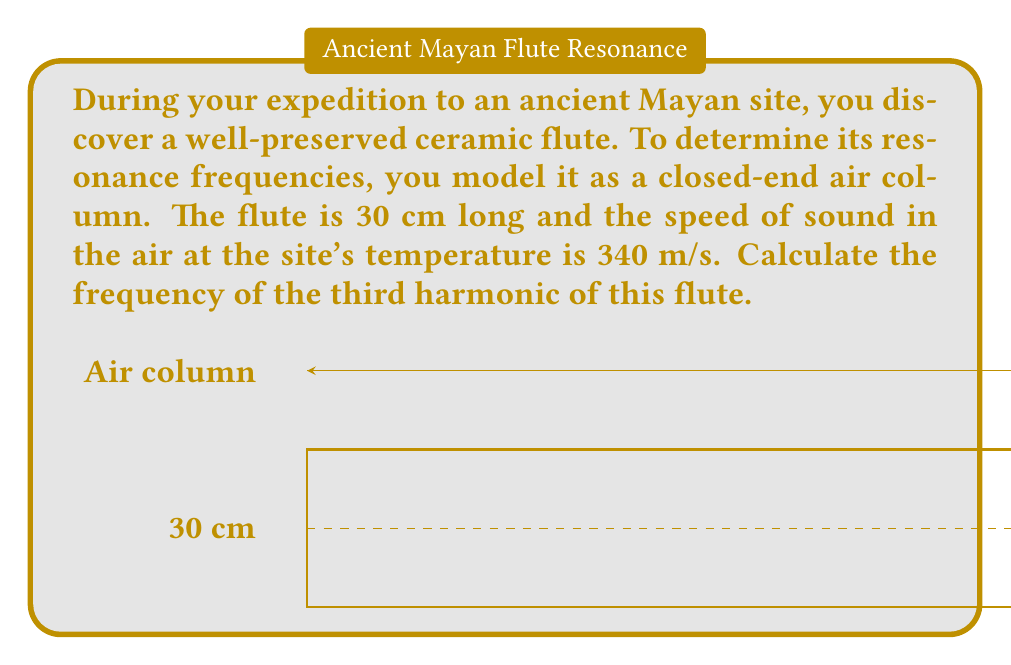Give your solution to this math problem. Let's approach this step-by-step:

1) For a closed-end air column, the resonance frequencies are given by the formula:

   $$f_n = \frac{v}{4L}(2n-1)$$

   Where:
   $f_n$ is the frequency of the nth harmonic
   $v$ is the speed of sound
   $L$ is the length of the air column
   $n$ is the harmonic number (1, 2, 3, ...)

2) We're asked to find the third harmonic, so $n = 3$.

3) We're given:
   $L = 30 \text{ cm} = 0.30 \text{ m}$
   $v = 340 \text{ m/s}$

4) Let's substitute these values into our equation:

   $$f_3 = \frac{340}{4(0.30)}(2(3)-1)$$

5) Simplify:
   $$f_3 = \frac{340}{1.20}(5)$$

6) Calculate:
   $$f_3 = 283.33 \cdot 5 = 1416.67 \text{ Hz}$$

7) Round to a reasonable number of significant figures:

   $$f_3 \approx 1417 \text{ Hz}$$
Answer: 1417 Hz 